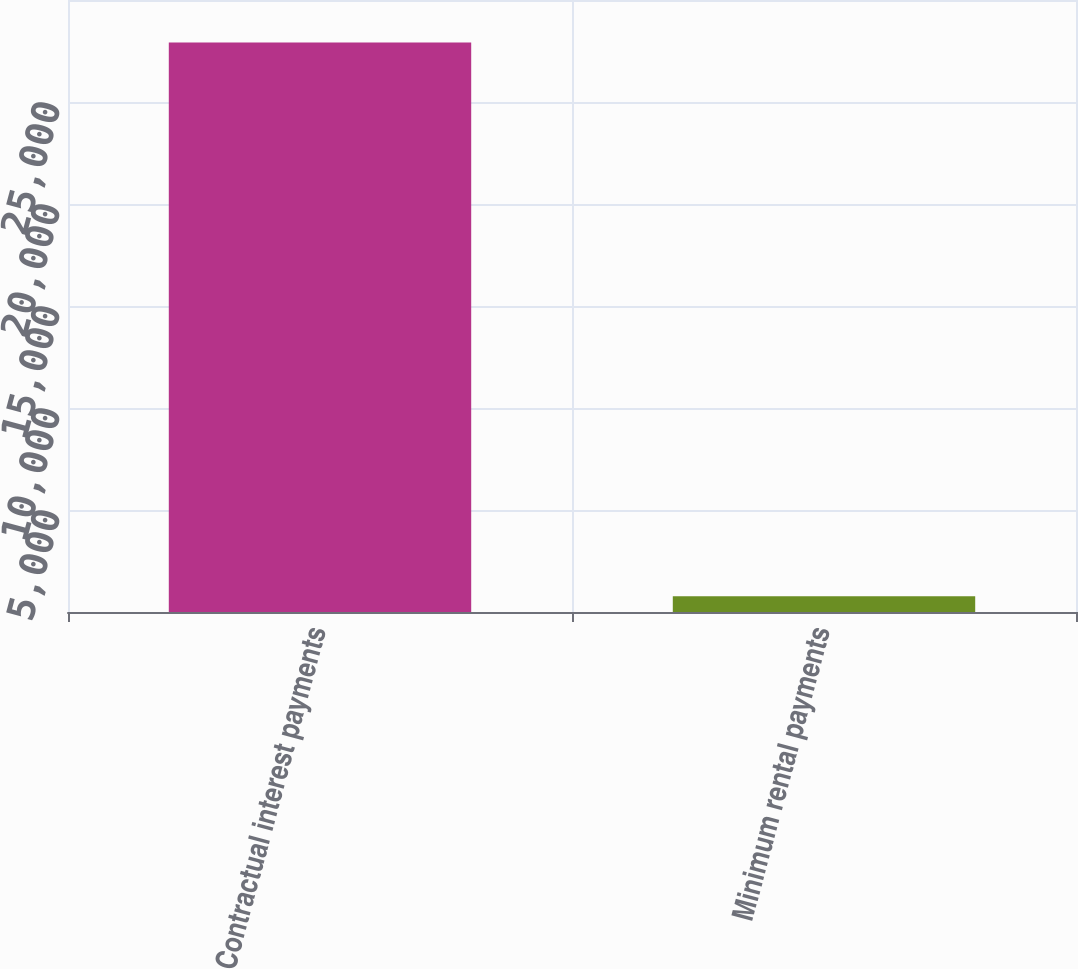<chart> <loc_0><loc_0><loc_500><loc_500><bar_chart><fcel>Contractual interest payments<fcel>Minimum rental payments<nl><fcel>27915<fcel>771<nl></chart> 